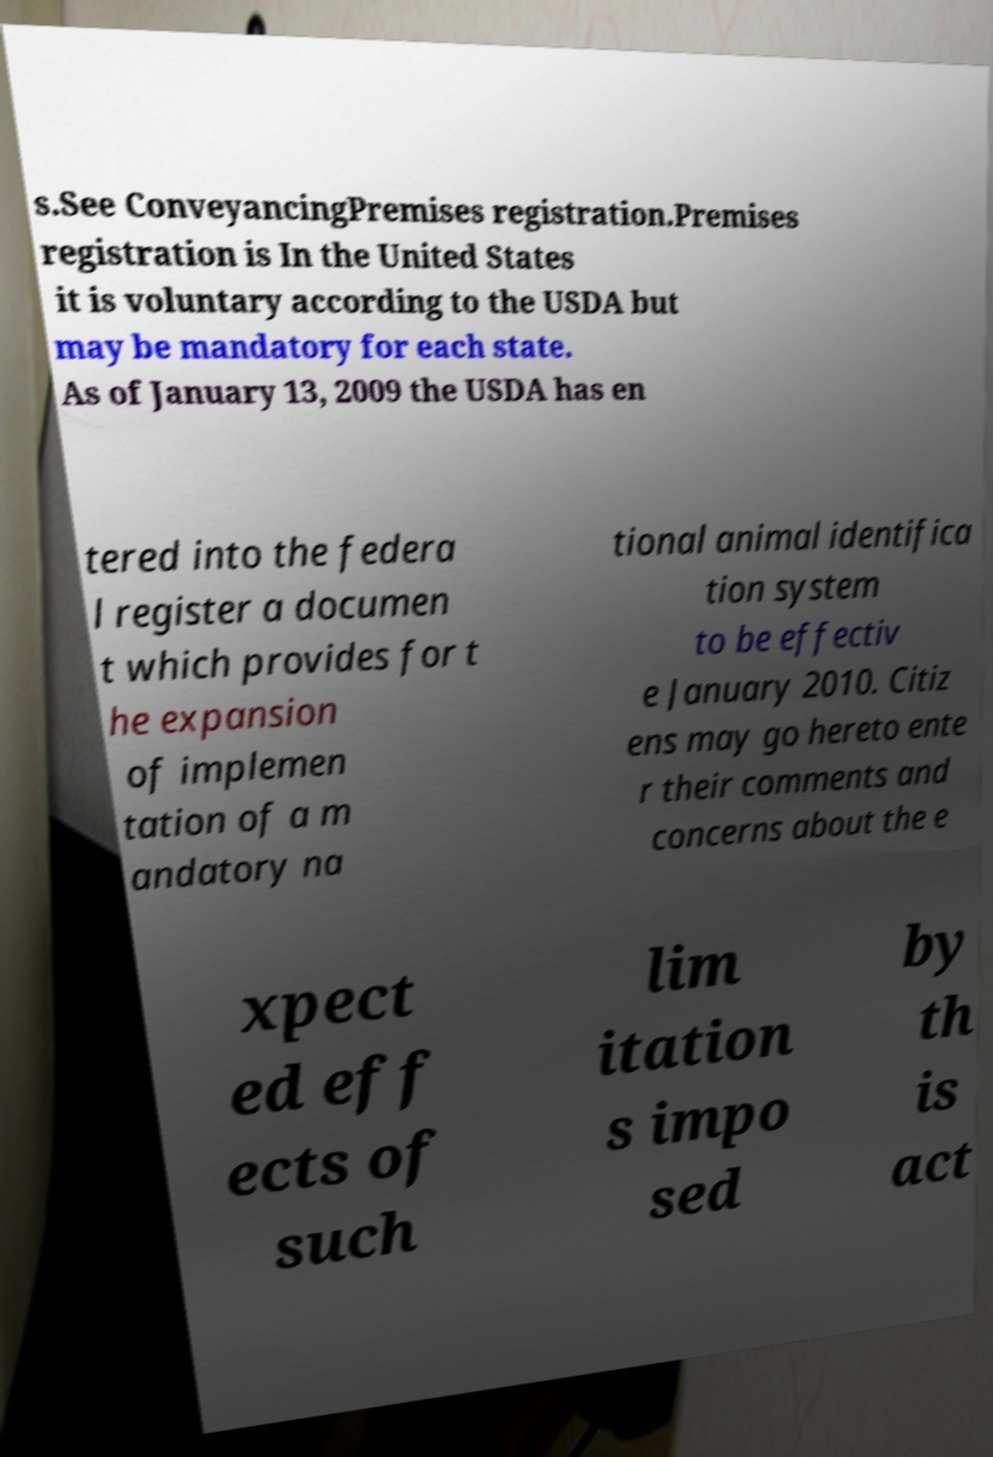There's text embedded in this image that I need extracted. Can you transcribe it verbatim? s.See ConveyancingPremises registration.Premises registration is In the United States it is voluntary according to the USDA but may be mandatory for each state. As of January 13, 2009 the USDA has en tered into the federa l register a documen t which provides for t he expansion of implemen tation of a m andatory na tional animal identifica tion system to be effectiv e January 2010. Citiz ens may go hereto ente r their comments and concerns about the e xpect ed eff ects of such lim itation s impo sed by th is act 